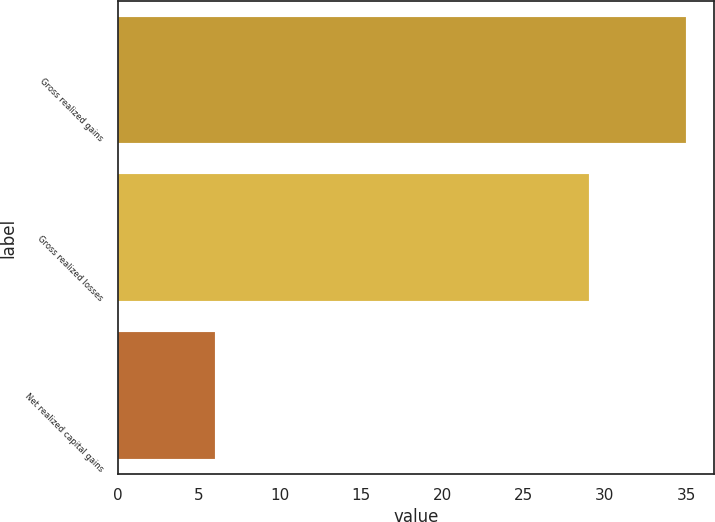Convert chart. <chart><loc_0><loc_0><loc_500><loc_500><bar_chart><fcel>Gross realized gains<fcel>Gross realized losses<fcel>Net realized capital gains<nl><fcel>35<fcel>29<fcel>6<nl></chart> 